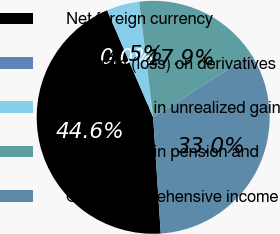<chart> <loc_0><loc_0><loc_500><loc_500><pie_chart><fcel>Net foreign currency<fcel>Net gain (loss) on derivatives<fcel>Net change in unrealized gain<fcel>Net change in pension and<fcel>Other comprehensive income<nl><fcel>44.57%<fcel>0.05%<fcel>4.5%<fcel>17.86%<fcel>33.03%<nl></chart> 